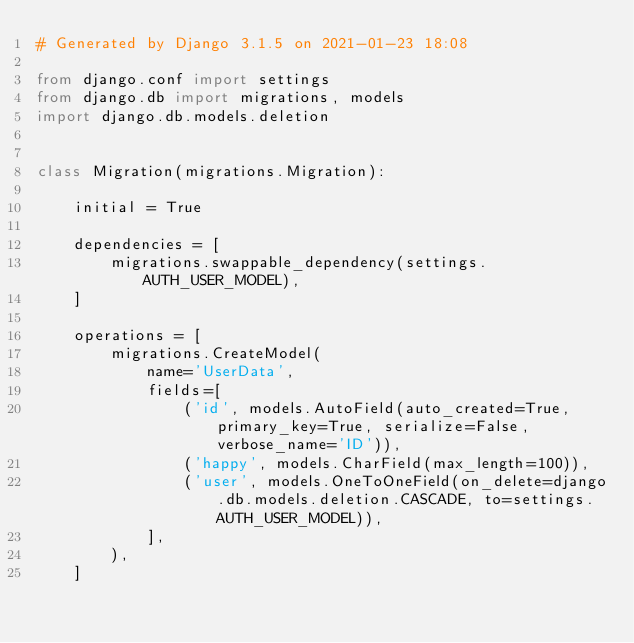Convert code to text. <code><loc_0><loc_0><loc_500><loc_500><_Python_># Generated by Django 3.1.5 on 2021-01-23 18:08

from django.conf import settings
from django.db import migrations, models
import django.db.models.deletion


class Migration(migrations.Migration):

    initial = True

    dependencies = [
        migrations.swappable_dependency(settings.AUTH_USER_MODEL),
    ]

    operations = [
        migrations.CreateModel(
            name='UserData',
            fields=[
                ('id', models.AutoField(auto_created=True, primary_key=True, serialize=False, verbose_name='ID')),
                ('happy', models.CharField(max_length=100)),
                ('user', models.OneToOneField(on_delete=django.db.models.deletion.CASCADE, to=settings.AUTH_USER_MODEL)),
            ],
        ),
    ]
</code> 